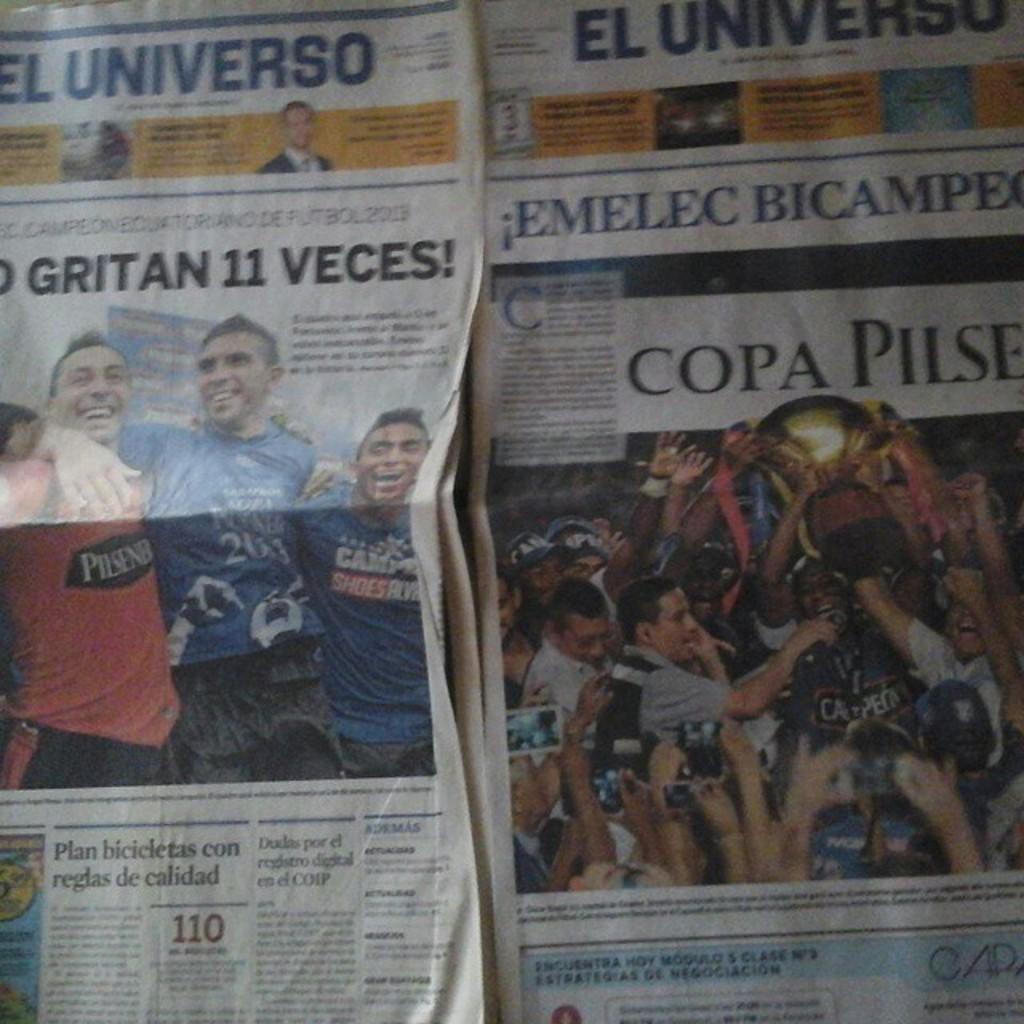How would you summarize this image in a sentence or two? In this picture we can see newspaper. We can see some information. 